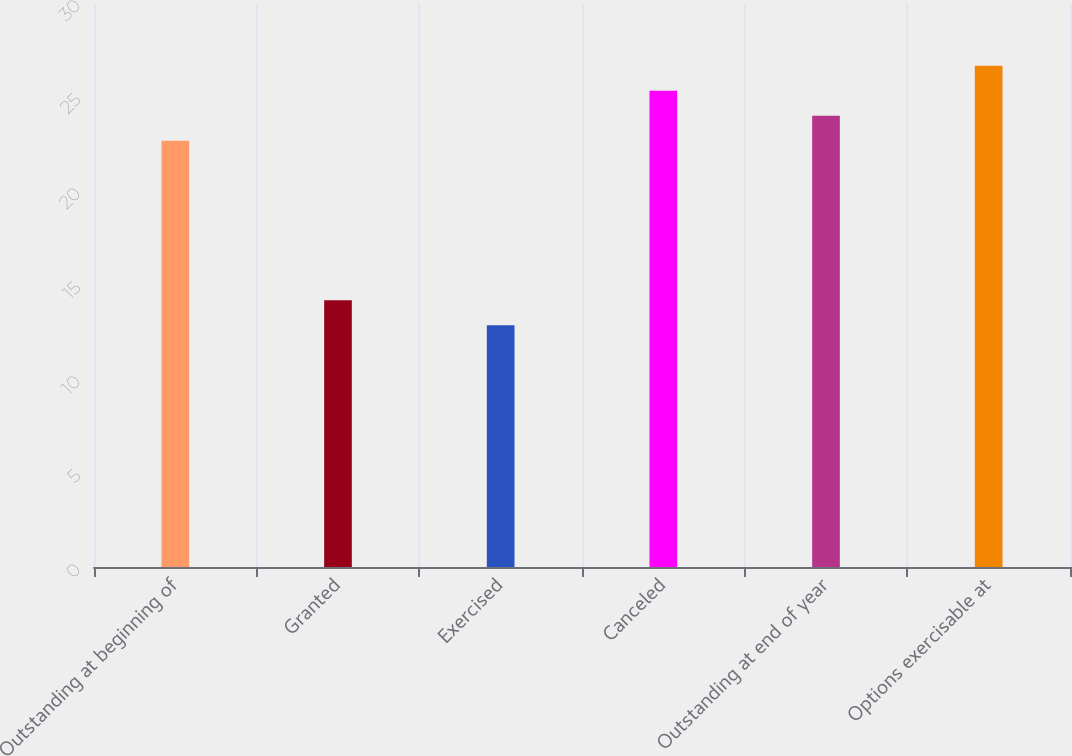<chart> <loc_0><loc_0><loc_500><loc_500><bar_chart><fcel>Outstanding at beginning of<fcel>Granted<fcel>Exercised<fcel>Canceled<fcel>Outstanding at end of year<fcel>Options exercisable at<nl><fcel>22.67<fcel>14.19<fcel>12.86<fcel>25.33<fcel>24<fcel>26.66<nl></chart> 